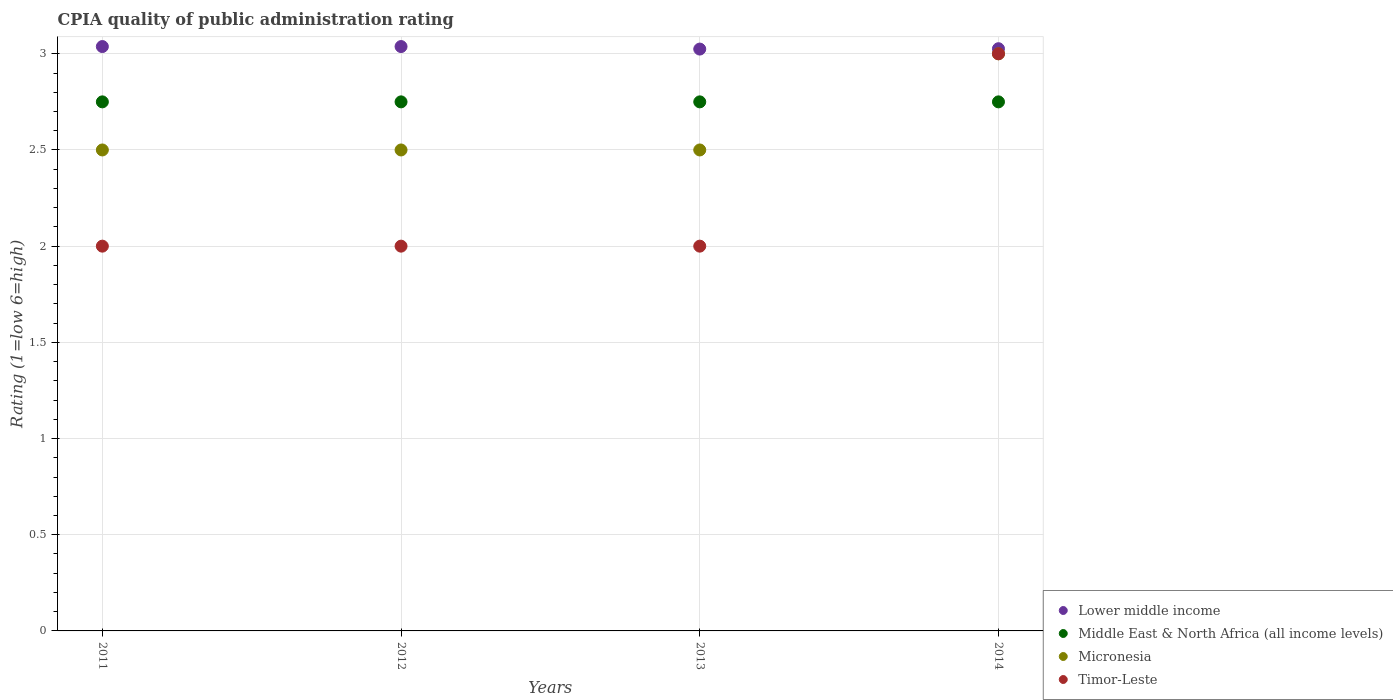How many different coloured dotlines are there?
Your answer should be very brief. 4. What is the CPIA rating in Timor-Leste in 2011?
Your answer should be compact. 2. Across all years, what is the maximum CPIA rating in Middle East & North Africa (all income levels)?
Offer a very short reply. 2.75. What is the total CPIA rating in Lower middle income in the graph?
Keep it short and to the point. 12.13. What is the difference between the CPIA rating in Lower middle income in 2011 and that in 2013?
Keep it short and to the point. 0.01. What is the difference between the CPIA rating in Timor-Leste in 2011 and the CPIA rating in Middle East & North Africa (all income levels) in 2013?
Provide a succinct answer. -0.75. What is the average CPIA rating in Micronesia per year?
Offer a terse response. 2.62. In the year 2013, what is the difference between the CPIA rating in Timor-Leste and CPIA rating in Lower middle income?
Your answer should be compact. -1.02. In how many years, is the CPIA rating in Timor-Leste greater than 1.8?
Ensure brevity in your answer.  4. What is the ratio of the CPIA rating in Timor-Leste in 2011 to that in 2014?
Provide a succinct answer. 0.67. Is the CPIA rating in Lower middle income in 2012 less than that in 2013?
Offer a terse response. No. Is the difference between the CPIA rating in Timor-Leste in 2011 and 2012 greater than the difference between the CPIA rating in Lower middle income in 2011 and 2012?
Offer a terse response. No. What is the difference between the highest and the lowest CPIA rating in Timor-Leste?
Offer a terse response. 1. Is the sum of the CPIA rating in Timor-Leste in 2013 and 2014 greater than the maximum CPIA rating in Middle East & North Africa (all income levels) across all years?
Your response must be concise. Yes. Is it the case that in every year, the sum of the CPIA rating in Micronesia and CPIA rating in Timor-Leste  is greater than the sum of CPIA rating in Middle East & North Africa (all income levels) and CPIA rating in Lower middle income?
Your answer should be very brief. No. Does the CPIA rating in Middle East & North Africa (all income levels) monotonically increase over the years?
Give a very brief answer. No. Is the CPIA rating in Middle East & North Africa (all income levels) strictly greater than the CPIA rating in Lower middle income over the years?
Provide a succinct answer. No. How many years are there in the graph?
Give a very brief answer. 4. Are the values on the major ticks of Y-axis written in scientific E-notation?
Provide a succinct answer. No. How many legend labels are there?
Offer a very short reply. 4. What is the title of the graph?
Provide a succinct answer. CPIA quality of public administration rating. What is the label or title of the X-axis?
Keep it short and to the point. Years. What is the Rating (1=low 6=high) in Lower middle income in 2011?
Your response must be concise. 3.04. What is the Rating (1=low 6=high) of Middle East & North Africa (all income levels) in 2011?
Your response must be concise. 2.75. What is the Rating (1=low 6=high) in Micronesia in 2011?
Give a very brief answer. 2.5. What is the Rating (1=low 6=high) of Timor-Leste in 2011?
Make the answer very short. 2. What is the Rating (1=low 6=high) in Lower middle income in 2012?
Your answer should be very brief. 3.04. What is the Rating (1=low 6=high) of Middle East & North Africa (all income levels) in 2012?
Your response must be concise. 2.75. What is the Rating (1=low 6=high) of Lower middle income in 2013?
Give a very brief answer. 3.02. What is the Rating (1=low 6=high) of Middle East & North Africa (all income levels) in 2013?
Offer a very short reply. 2.75. What is the Rating (1=low 6=high) of Lower middle income in 2014?
Make the answer very short. 3.03. What is the Rating (1=low 6=high) in Middle East & North Africa (all income levels) in 2014?
Make the answer very short. 2.75. What is the Rating (1=low 6=high) in Micronesia in 2014?
Offer a very short reply. 3. Across all years, what is the maximum Rating (1=low 6=high) of Lower middle income?
Offer a terse response. 3.04. Across all years, what is the maximum Rating (1=low 6=high) of Middle East & North Africa (all income levels)?
Offer a terse response. 2.75. Across all years, what is the minimum Rating (1=low 6=high) of Lower middle income?
Keep it short and to the point. 3.02. Across all years, what is the minimum Rating (1=low 6=high) in Middle East & North Africa (all income levels)?
Give a very brief answer. 2.75. Across all years, what is the minimum Rating (1=low 6=high) in Micronesia?
Provide a succinct answer. 2.5. Across all years, what is the minimum Rating (1=low 6=high) of Timor-Leste?
Ensure brevity in your answer.  2. What is the total Rating (1=low 6=high) of Lower middle income in the graph?
Make the answer very short. 12.13. What is the difference between the Rating (1=low 6=high) in Middle East & North Africa (all income levels) in 2011 and that in 2012?
Provide a short and direct response. 0. What is the difference between the Rating (1=low 6=high) of Lower middle income in 2011 and that in 2013?
Provide a succinct answer. 0.01. What is the difference between the Rating (1=low 6=high) in Middle East & North Africa (all income levels) in 2011 and that in 2013?
Offer a very short reply. 0. What is the difference between the Rating (1=low 6=high) in Micronesia in 2011 and that in 2013?
Provide a short and direct response. 0. What is the difference between the Rating (1=low 6=high) of Timor-Leste in 2011 and that in 2013?
Keep it short and to the point. 0. What is the difference between the Rating (1=low 6=high) in Lower middle income in 2011 and that in 2014?
Keep it short and to the point. 0.01. What is the difference between the Rating (1=low 6=high) of Timor-Leste in 2011 and that in 2014?
Provide a short and direct response. -1. What is the difference between the Rating (1=low 6=high) in Lower middle income in 2012 and that in 2013?
Make the answer very short. 0.01. What is the difference between the Rating (1=low 6=high) in Micronesia in 2012 and that in 2013?
Keep it short and to the point. 0. What is the difference between the Rating (1=low 6=high) of Timor-Leste in 2012 and that in 2013?
Provide a succinct answer. 0. What is the difference between the Rating (1=low 6=high) in Lower middle income in 2012 and that in 2014?
Your response must be concise. 0.01. What is the difference between the Rating (1=low 6=high) of Middle East & North Africa (all income levels) in 2012 and that in 2014?
Provide a short and direct response. 0. What is the difference between the Rating (1=low 6=high) in Lower middle income in 2013 and that in 2014?
Your answer should be very brief. -0. What is the difference between the Rating (1=low 6=high) of Lower middle income in 2011 and the Rating (1=low 6=high) of Middle East & North Africa (all income levels) in 2012?
Your response must be concise. 0.29. What is the difference between the Rating (1=low 6=high) of Lower middle income in 2011 and the Rating (1=low 6=high) of Micronesia in 2012?
Provide a succinct answer. 0.54. What is the difference between the Rating (1=low 6=high) of Lower middle income in 2011 and the Rating (1=low 6=high) of Timor-Leste in 2012?
Offer a very short reply. 1.04. What is the difference between the Rating (1=low 6=high) in Middle East & North Africa (all income levels) in 2011 and the Rating (1=low 6=high) in Micronesia in 2012?
Provide a short and direct response. 0.25. What is the difference between the Rating (1=low 6=high) in Micronesia in 2011 and the Rating (1=low 6=high) in Timor-Leste in 2012?
Your response must be concise. 0.5. What is the difference between the Rating (1=low 6=high) of Lower middle income in 2011 and the Rating (1=low 6=high) of Middle East & North Africa (all income levels) in 2013?
Keep it short and to the point. 0.29. What is the difference between the Rating (1=low 6=high) in Lower middle income in 2011 and the Rating (1=low 6=high) in Micronesia in 2013?
Ensure brevity in your answer.  0.54. What is the difference between the Rating (1=low 6=high) of Lower middle income in 2011 and the Rating (1=low 6=high) of Timor-Leste in 2013?
Your response must be concise. 1.04. What is the difference between the Rating (1=low 6=high) in Middle East & North Africa (all income levels) in 2011 and the Rating (1=low 6=high) in Timor-Leste in 2013?
Provide a short and direct response. 0.75. What is the difference between the Rating (1=low 6=high) in Lower middle income in 2011 and the Rating (1=low 6=high) in Middle East & North Africa (all income levels) in 2014?
Offer a very short reply. 0.29. What is the difference between the Rating (1=low 6=high) in Lower middle income in 2011 and the Rating (1=low 6=high) in Micronesia in 2014?
Make the answer very short. 0.04. What is the difference between the Rating (1=low 6=high) of Lower middle income in 2011 and the Rating (1=low 6=high) of Timor-Leste in 2014?
Keep it short and to the point. 0.04. What is the difference between the Rating (1=low 6=high) of Middle East & North Africa (all income levels) in 2011 and the Rating (1=low 6=high) of Micronesia in 2014?
Offer a very short reply. -0.25. What is the difference between the Rating (1=low 6=high) of Middle East & North Africa (all income levels) in 2011 and the Rating (1=low 6=high) of Timor-Leste in 2014?
Your answer should be compact. -0.25. What is the difference between the Rating (1=low 6=high) in Lower middle income in 2012 and the Rating (1=low 6=high) in Middle East & North Africa (all income levels) in 2013?
Your response must be concise. 0.29. What is the difference between the Rating (1=low 6=high) of Lower middle income in 2012 and the Rating (1=low 6=high) of Micronesia in 2013?
Provide a short and direct response. 0.54. What is the difference between the Rating (1=low 6=high) in Lower middle income in 2012 and the Rating (1=low 6=high) in Timor-Leste in 2013?
Make the answer very short. 1.04. What is the difference between the Rating (1=low 6=high) of Middle East & North Africa (all income levels) in 2012 and the Rating (1=low 6=high) of Micronesia in 2013?
Keep it short and to the point. 0.25. What is the difference between the Rating (1=low 6=high) of Middle East & North Africa (all income levels) in 2012 and the Rating (1=low 6=high) of Timor-Leste in 2013?
Provide a short and direct response. 0.75. What is the difference between the Rating (1=low 6=high) of Lower middle income in 2012 and the Rating (1=low 6=high) of Middle East & North Africa (all income levels) in 2014?
Provide a succinct answer. 0.29. What is the difference between the Rating (1=low 6=high) of Lower middle income in 2012 and the Rating (1=low 6=high) of Micronesia in 2014?
Make the answer very short. 0.04. What is the difference between the Rating (1=low 6=high) of Lower middle income in 2012 and the Rating (1=low 6=high) of Timor-Leste in 2014?
Your answer should be compact. 0.04. What is the difference between the Rating (1=low 6=high) of Middle East & North Africa (all income levels) in 2012 and the Rating (1=low 6=high) of Micronesia in 2014?
Give a very brief answer. -0.25. What is the difference between the Rating (1=low 6=high) in Micronesia in 2012 and the Rating (1=low 6=high) in Timor-Leste in 2014?
Your answer should be compact. -0.5. What is the difference between the Rating (1=low 6=high) in Lower middle income in 2013 and the Rating (1=low 6=high) in Middle East & North Africa (all income levels) in 2014?
Provide a short and direct response. 0.27. What is the difference between the Rating (1=low 6=high) in Lower middle income in 2013 and the Rating (1=low 6=high) in Micronesia in 2014?
Ensure brevity in your answer.  0.02. What is the difference between the Rating (1=low 6=high) in Lower middle income in 2013 and the Rating (1=low 6=high) in Timor-Leste in 2014?
Give a very brief answer. 0.02. What is the difference between the Rating (1=low 6=high) in Middle East & North Africa (all income levels) in 2013 and the Rating (1=low 6=high) in Timor-Leste in 2014?
Provide a succinct answer. -0.25. What is the difference between the Rating (1=low 6=high) of Micronesia in 2013 and the Rating (1=low 6=high) of Timor-Leste in 2014?
Provide a succinct answer. -0.5. What is the average Rating (1=low 6=high) in Lower middle income per year?
Provide a succinct answer. 3.03. What is the average Rating (1=low 6=high) in Middle East & North Africa (all income levels) per year?
Give a very brief answer. 2.75. What is the average Rating (1=low 6=high) in Micronesia per year?
Keep it short and to the point. 2.62. What is the average Rating (1=low 6=high) of Timor-Leste per year?
Provide a succinct answer. 2.25. In the year 2011, what is the difference between the Rating (1=low 6=high) of Lower middle income and Rating (1=low 6=high) of Middle East & North Africa (all income levels)?
Your answer should be compact. 0.29. In the year 2011, what is the difference between the Rating (1=low 6=high) of Lower middle income and Rating (1=low 6=high) of Micronesia?
Offer a very short reply. 0.54. In the year 2011, what is the difference between the Rating (1=low 6=high) of Lower middle income and Rating (1=low 6=high) of Timor-Leste?
Keep it short and to the point. 1.04. In the year 2011, what is the difference between the Rating (1=low 6=high) of Middle East & North Africa (all income levels) and Rating (1=low 6=high) of Timor-Leste?
Give a very brief answer. 0.75. In the year 2011, what is the difference between the Rating (1=low 6=high) of Micronesia and Rating (1=low 6=high) of Timor-Leste?
Offer a very short reply. 0.5. In the year 2012, what is the difference between the Rating (1=low 6=high) of Lower middle income and Rating (1=low 6=high) of Middle East & North Africa (all income levels)?
Offer a very short reply. 0.29. In the year 2012, what is the difference between the Rating (1=low 6=high) in Lower middle income and Rating (1=low 6=high) in Micronesia?
Offer a terse response. 0.54. In the year 2012, what is the difference between the Rating (1=low 6=high) of Lower middle income and Rating (1=low 6=high) of Timor-Leste?
Offer a very short reply. 1.04. In the year 2012, what is the difference between the Rating (1=low 6=high) of Middle East & North Africa (all income levels) and Rating (1=low 6=high) of Timor-Leste?
Your answer should be compact. 0.75. In the year 2012, what is the difference between the Rating (1=low 6=high) of Micronesia and Rating (1=low 6=high) of Timor-Leste?
Offer a very short reply. 0.5. In the year 2013, what is the difference between the Rating (1=low 6=high) of Lower middle income and Rating (1=low 6=high) of Middle East & North Africa (all income levels)?
Give a very brief answer. 0.27. In the year 2013, what is the difference between the Rating (1=low 6=high) of Lower middle income and Rating (1=low 6=high) of Micronesia?
Your answer should be very brief. 0.52. In the year 2013, what is the difference between the Rating (1=low 6=high) in Lower middle income and Rating (1=low 6=high) in Timor-Leste?
Give a very brief answer. 1.02. In the year 2013, what is the difference between the Rating (1=low 6=high) in Middle East & North Africa (all income levels) and Rating (1=low 6=high) in Micronesia?
Ensure brevity in your answer.  0.25. In the year 2013, what is the difference between the Rating (1=low 6=high) in Middle East & North Africa (all income levels) and Rating (1=low 6=high) in Timor-Leste?
Ensure brevity in your answer.  0.75. In the year 2013, what is the difference between the Rating (1=low 6=high) of Micronesia and Rating (1=low 6=high) of Timor-Leste?
Your answer should be very brief. 0.5. In the year 2014, what is the difference between the Rating (1=low 6=high) of Lower middle income and Rating (1=low 6=high) of Middle East & North Africa (all income levels)?
Make the answer very short. 0.28. In the year 2014, what is the difference between the Rating (1=low 6=high) in Lower middle income and Rating (1=low 6=high) in Micronesia?
Provide a short and direct response. 0.03. In the year 2014, what is the difference between the Rating (1=low 6=high) in Lower middle income and Rating (1=low 6=high) in Timor-Leste?
Make the answer very short. 0.03. In the year 2014, what is the difference between the Rating (1=low 6=high) of Middle East & North Africa (all income levels) and Rating (1=low 6=high) of Micronesia?
Offer a very short reply. -0.25. In the year 2014, what is the difference between the Rating (1=low 6=high) of Middle East & North Africa (all income levels) and Rating (1=low 6=high) of Timor-Leste?
Keep it short and to the point. -0.25. In the year 2014, what is the difference between the Rating (1=low 6=high) in Micronesia and Rating (1=low 6=high) in Timor-Leste?
Make the answer very short. 0. What is the ratio of the Rating (1=low 6=high) of Micronesia in 2011 to that in 2012?
Ensure brevity in your answer.  1. What is the ratio of the Rating (1=low 6=high) in Timor-Leste in 2011 to that in 2012?
Give a very brief answer. 1. What is the ratio of the Rating (1=low 6=high) of Middle East & North Africa (all income levels) in 2011 to that in 2013?
Your response must be concise. 1. What is the ratio of the Rating (1=low 6=high) of Middle East & North Africa (all income levels) in 2011 to that in 2014?
Ensure brevity in your answer.  1. What is the ratio of the Rating (1=low 6=high) of Micronesia in 2011 to that in 2014?
Offer a very short reply. 0.83. What is the ratio of the Rating (1=low 6=high) of Lower middle income in 2012 to that in 2013?
Offer a very short reply. 1. What is the ratio of the Rating (1=low 6=high) of Middle East & North Africa (all income levels) in 2012 to that in 2013?
Offer a terse response. 1. What is the ratio of the Rating (1=low 6=high) of Micronesia in 2012 to that in 2013?
Offer a terse response. 1. What is the ratio of the Rating (1=low 6=high) of Timor-Leste in 2012 to that in 2013?
Your answer should be compact. 1. What is the ratio of the Rating (1=low 6=high) in Middle East & North Africa (all income levels) in 2012 to that in 2014?
Provide a succinct answer. 1. What is the ratio of the Rating (1=low 6=high) in Timor-Leste in 2012 to that in 2014?
Provide a succinct answer. 0.67. What is the ratio of the Rating (1=low 6=high) of Timor-Leste in 2013 to that in 2014?
Your answer should be compact. 0.67. What is the difference between the highest and the second highest Rating (1=low 6=high) of Lower middle income?
Offer a very short reply. 0. What is the difference between the highest and the second highest Rating (1=low 6=high) in Micronesia?
Offer a terse response. 0.5. What is the difference between the highest and the lowest Rating (1=low 6=high) in Lower middle income?
Offer a very short reply. 0.01. What is the difference between the highest and the lowest Rating (1=low 6=high) in Middle East & North Africa (all income levels)?
Provide a succinct answer. 0. What is the difference between the highest and the lowest Rating (1=low 6=high) in Micronesia?
Give a very brief answer. 0.5. 